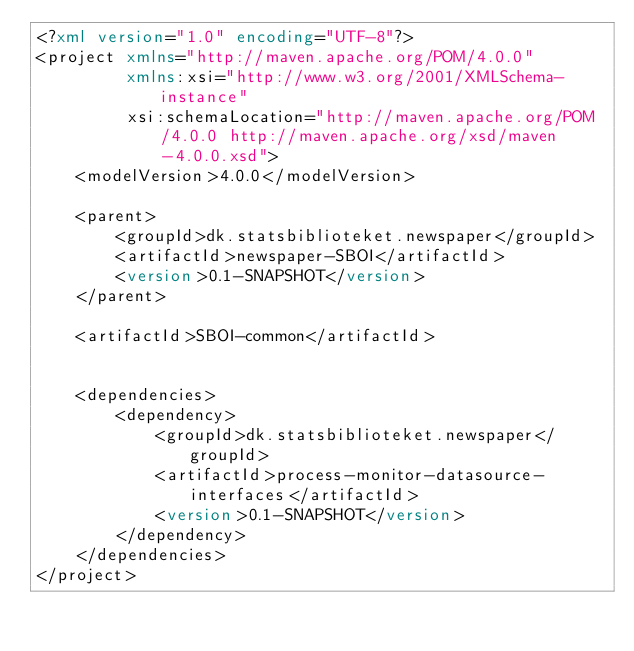<code> <loc_0><loc_0><loc_500><loc_500><_XML_><?xml version="1.0" encoding="UTF-8"?>
<project xmlns="http://maven.apache.org/POM/4.0.0"
         xmlns:xsi="http://www.w3.org/2001/XMLSchema-instance"
         xsi:schemaLocation="http://maven.apache.org/POM/4.0.0 http://maven.apache.org/xsd/maven-4.0.0.xsd">
    <modelVersion>4.0.0</modelVersion>

    <parent>
        <groupId>dk.statsbiblioteket.newspaper</groupId>
        <artifactId>newspaper-SBOI</artifactId>
        <version>0.1-SNAPSHOT</version>
    </parent>

    <artifactId>SBOI-common</artifactId>


    <dependencies>
        <dependency>
            <groupId>dk.statsbiblioteket.newspaper</groupId>
            <artifactId>process-monitor-datasource-interfaces</artifactId>
            <version>0.1-SNAPSHOT</version>
        </dependency>
    </dependencies>
</project></code> 